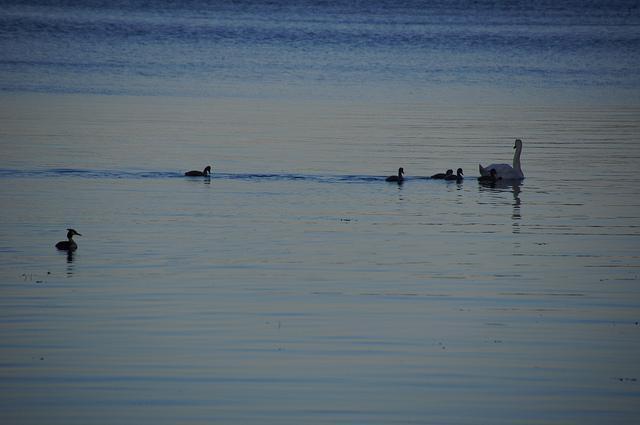What type of birds are the little ones?
Make your selection from the four choices given to correctly answer the question.
Options: Seagull, swan, duck, goose. Swan. 